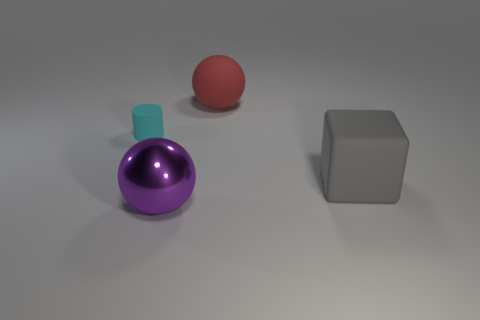Add 2 big brown metallic objects. How many objects exist? 6 Subtract all red balls. How many balls are left? 1 Subtract 1 balls. How many balls are left? 1 Subtract all yellow blocks. How many purple spheres are left? 1 Subtract all large green metal things. Subtract all metal spheres. How many objects are left? 3 Add 1 large metallic spheres. How many large metallic spheres are left? 2 Add 1 brown shiny objects. How many brown shiny objects exist? 1 Subtract 0 yellow balls. How many objects are left? 4 Subtract all cyan cubes. Subtract all gray spheres. How many cubes are left? 1 